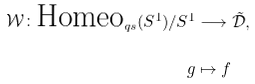<formula> <loc_0><loc_0><loc_500><loc_500>\mathcal { W } \colon \text {Homeo} _ { q s } ( S ^ { 1 } ) / S ^ { 1 } & \longrightarrow \tilde { \mathcal { D } } , \\ \ g & \mapsto f</formula> 